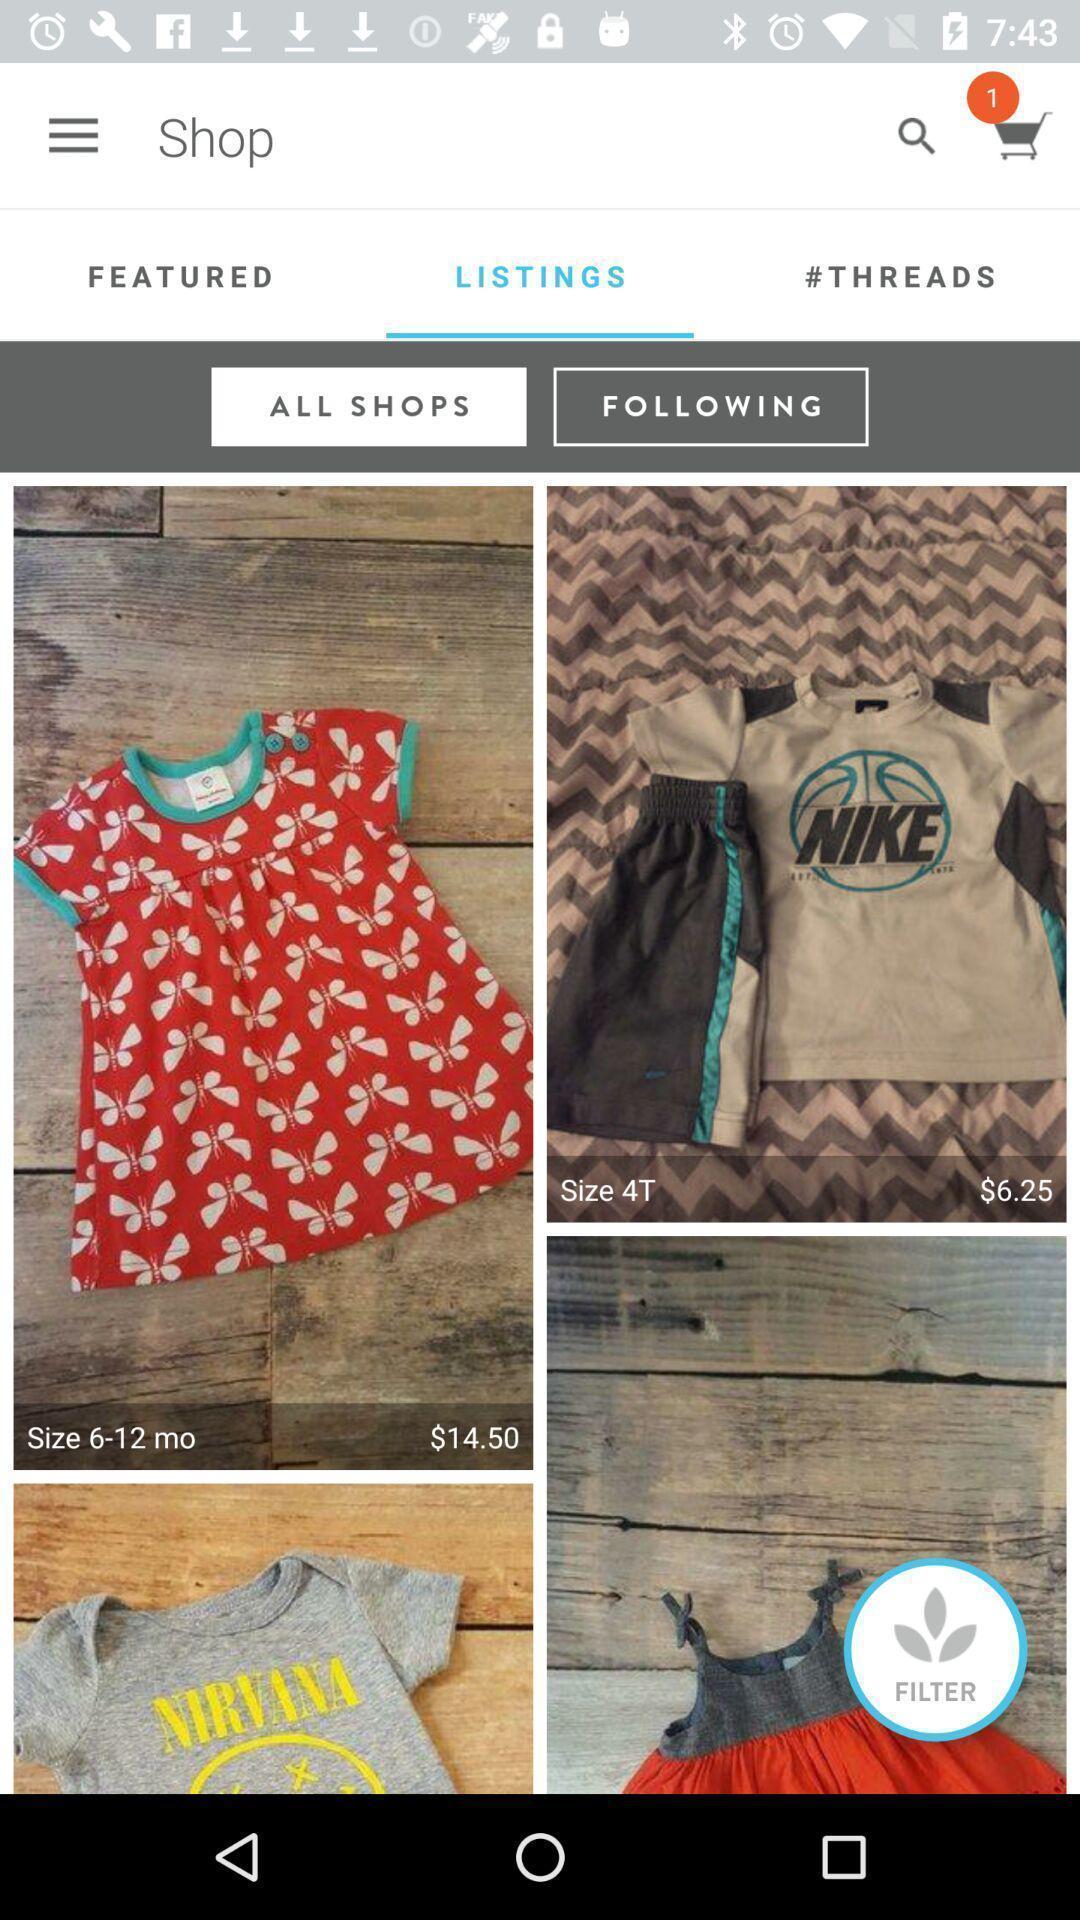Give me a narrative description of this picture. Shopping app displayed listings and other options. 